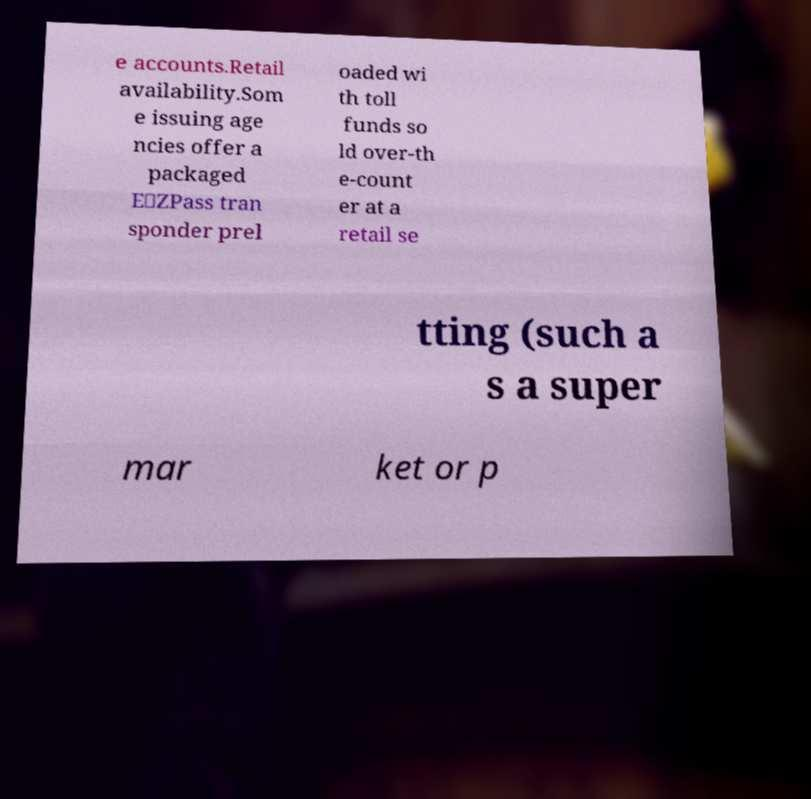Could you extract and type out the text from this image? e accounts.Retail availability.Som e issuing age ncies offer a packaged E‑ZPass tran sponder prel oaded wi th toll funds so ld over-th e-count er at a retail se tting (such a s a super mar ket or p 